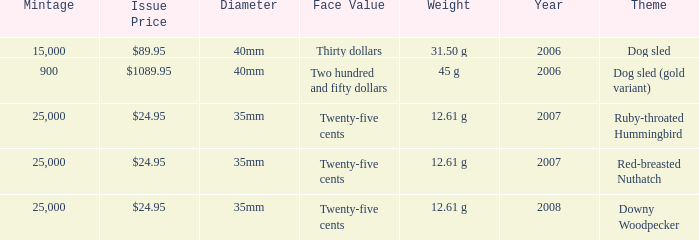What is the Year of the Coin with an Issue Price of $1089.95 and Mintage less than 900? None. 